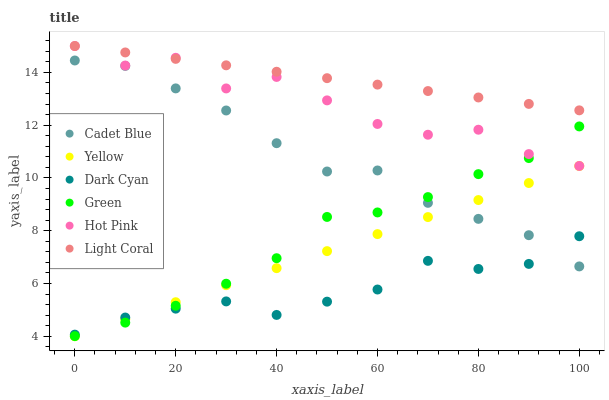Does Dark Cyan have the minimum area under the curve?
Answer yes or no. Yes. Does Light Coral have the maximum area under the curve?
Answer yes or no. Yes. Does Hot Pink have the minimum area under the curve?
Answer yes or no. No. Does Hot Pink have the maximum area under the curve?
Answer yes or no. No. Is Light Coral the smoothest?
Answer yes or no. Yes. Is Hot Pink the roughest?
Answer yes or no. Yes. Is Yellow the smoothest?
Answer yes or no. No. Is Yellow the roughest?
Answer yes or no. No. Does Yellow have the lowest value?
Answer yes or no. Yes. Does Hot Pink have the lowest value?
Answer yes or no. No. Does Light Coral have the highest value?
Answer yes or no. Yes. Does Yellow have the highest value?
Answer yes or no. No. Is Cadet Blue less than Light Coral?
Answer yes or no. Yes. Is Light Coral greater than Cadet Blue?
Answer yes or no. Yes. Does Green intersect Cadet Blue?
Answer yes or no. Yes. Is Green less than Cadet Blue?
Answer yes or no. No. Is Green greater than Cadet Blue?
Answer yes or no. No. Does Cadet Blue intersect Light Coral?
Answer yes or no. No. 